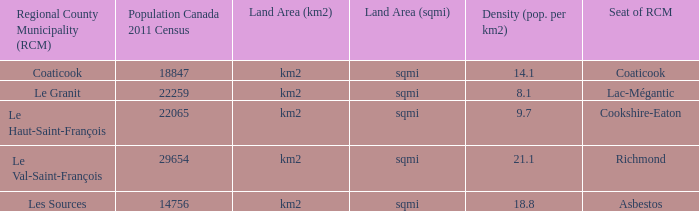7? Cookshire-Eaton. Help me parse the entirety of this table. {'header': ['Regional County Municipality (RCM)', 'Population Canada 2011 Census', 'Land Area (km2)', 'Land Area (sqmi)', 'Density (pop. per km2)', 'Seat of RCM'], 'rows': [['Coaticook', '18847', 'km2', 'sqmi', '14.1', 'Coaticook'], ['Le Granit', '22259', 'km2', 'sqmi', '8.1', 'Lac-Mégantic'], ['Le Haut-Saint-François', '22065', 'km2', 'sqmi', '9.7', 'Cookshire-Eaton'], ['Le Val-Saint-François', '29654', 'km2', 'sqmi', '21.1', 'Richmond'], ['Les Sources', '14756', 'km2', 'sqmi', '18.8', 'Asbestos']]} 